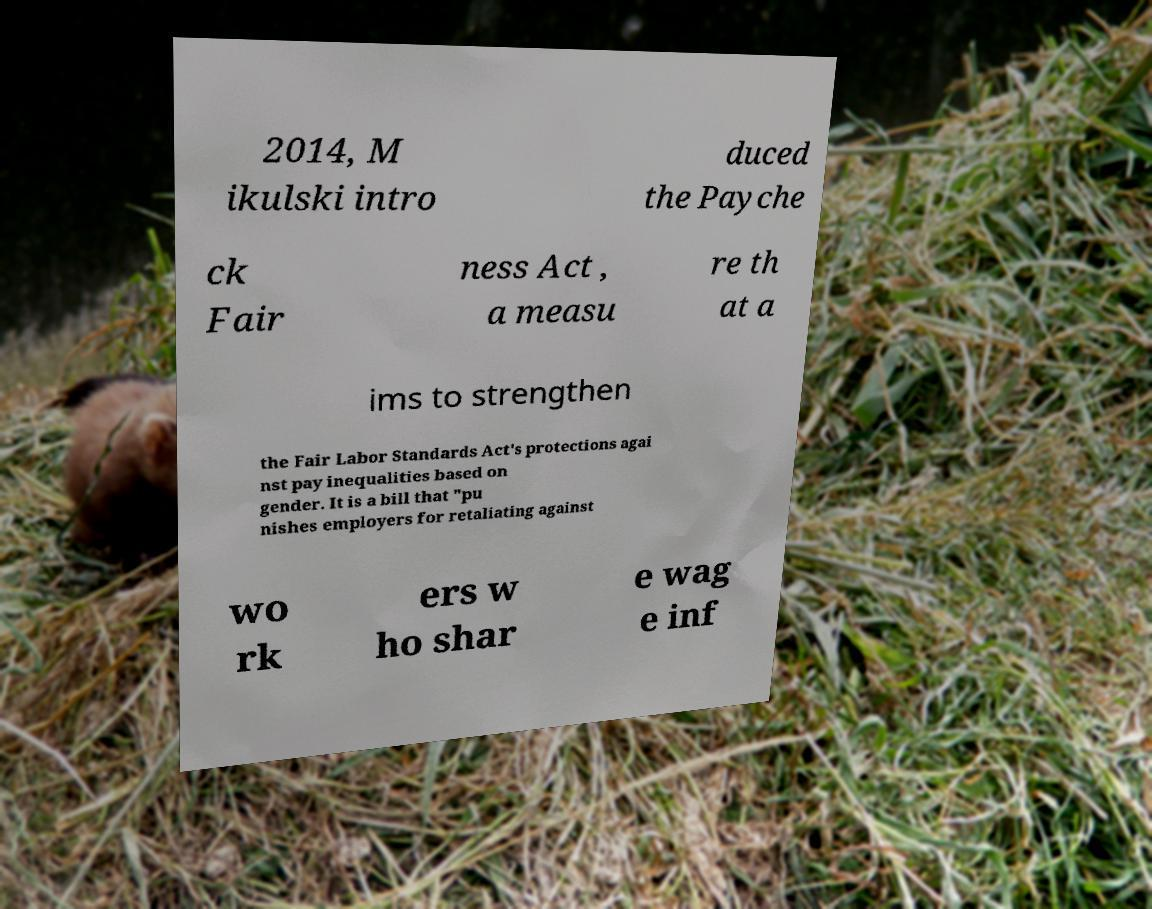Could you assist in decoding the text presented in this image and type it out clearly? 2014, M ikulski intro duced the Payche ck Fair ness Act , a measu re th at a ims to strengthen the Fair Labor Standards Act's protections agai nst pay inequalities based on gender. It is a bill that "pu nishes employers for retaliating against wo rk ers w ho shar e wag e inf 